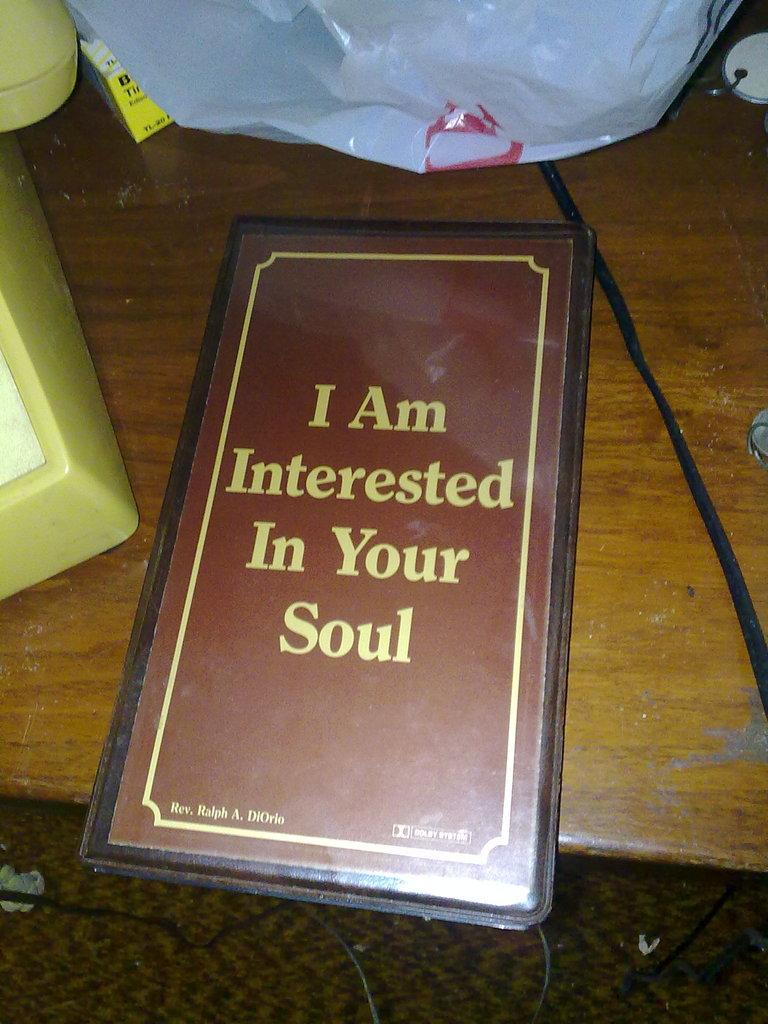What is the name of the book on the table?
Keep it short and to the point. I am interested in your soul. 